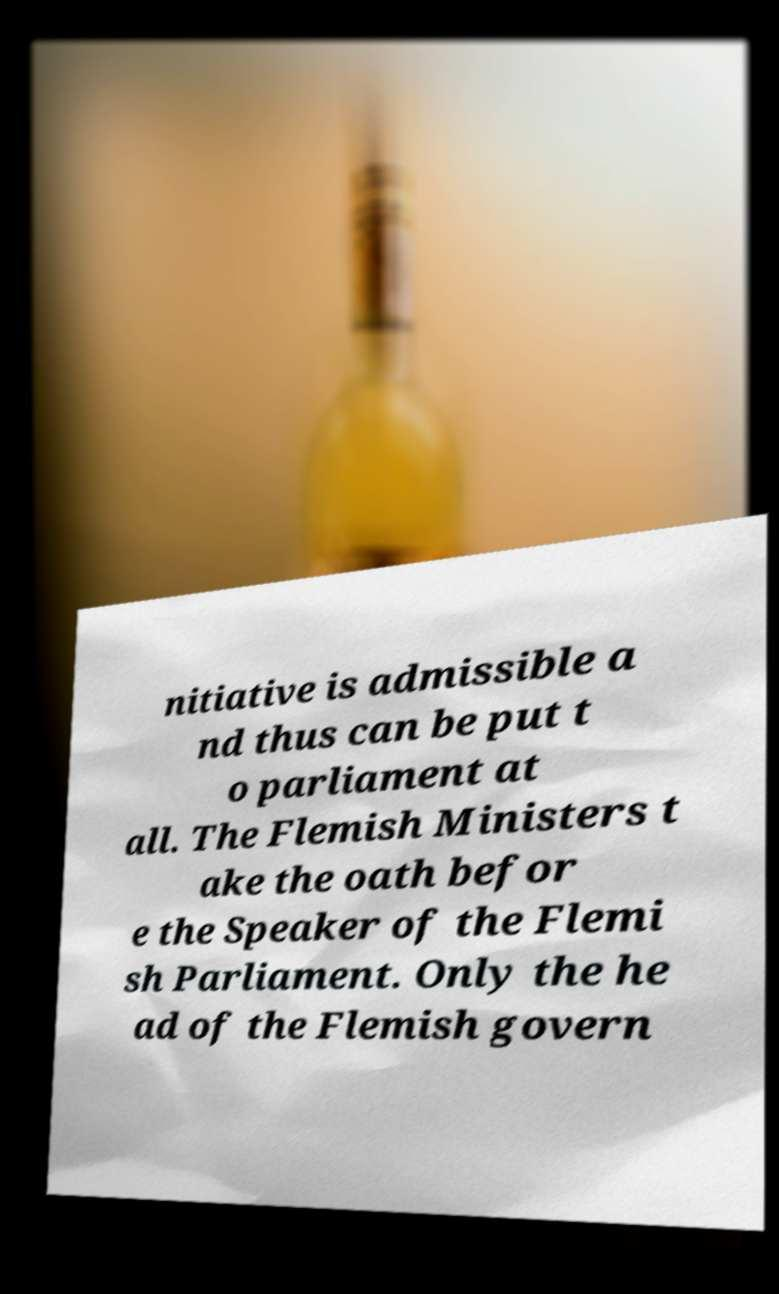Can you accurately transcribe the text from the provided image for me? nitiative is admissible a nd thus can be put t o parliament at all. The Flemish Ministers t ake the oath befor e the Speaker of the Flemi sh Parliament. Only the he ad of the Flemish govern 